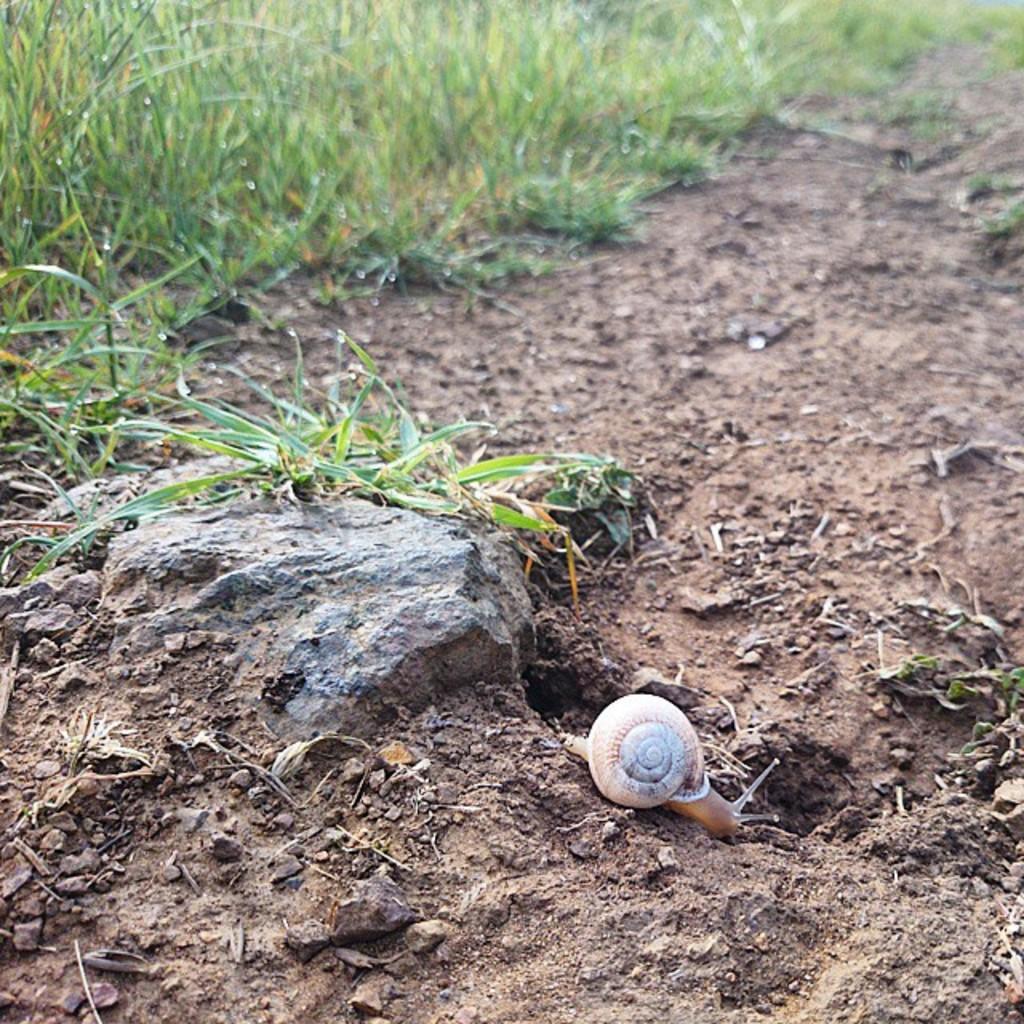In one or two sentences, can you explain what this image depicts? In this image I can see the shell on the ground. The shell is in brown color. To the side I can see the rock and the green color grass. 